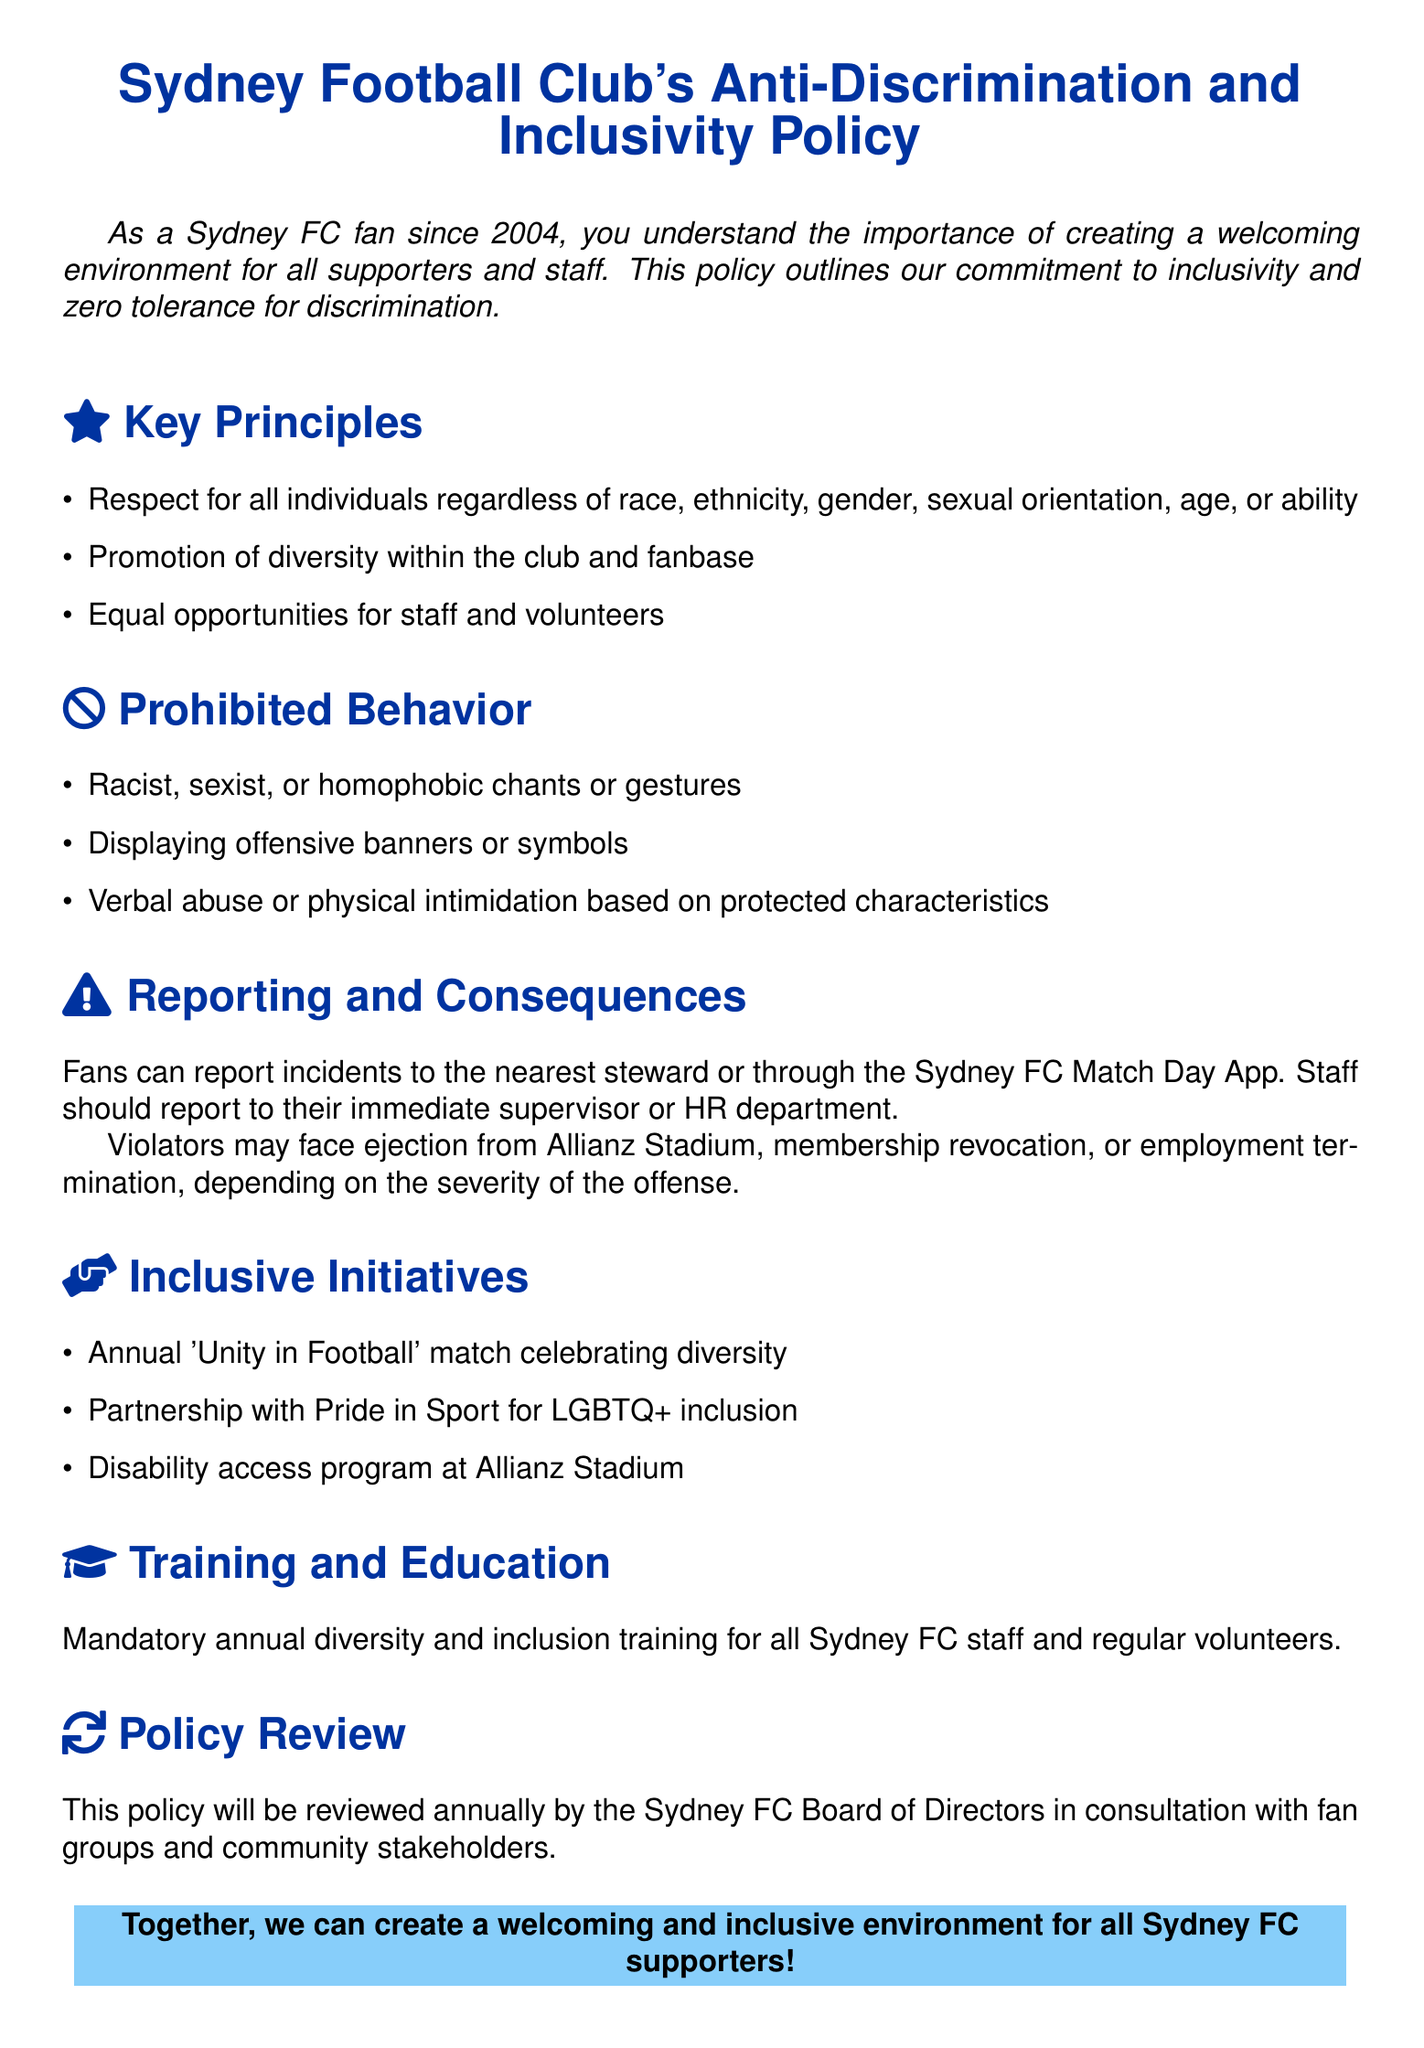What are the key principles of the policy? The key principles are outlined in the "Key Principles" section, which includes respect for all individuals, promotion of diversity, and equal opportunities.
Answer: Respect for all individuals, promotion of diversity, equal opportunities What actions are prohibited according to the policy? The prohibited behaviors are mentioned in the "Prohibited Behavior" section, which lists specific actions that violate the policy.
Answer: Racist, sexist, or homophobic chants or gestures, displaying offensive banners or symbols, verbal abuse or physical intimidation How can fans report incidents? The document states where incidents can be reported, specifically mentioning stewards and the match day app.
Answer: Nearest steward or through the Sydney FC Match Day App What are the potential consequences for violators? The document lists the possible consequences in the "Reporting and Consequences" section, detailing actions taken against offenders.
Answer: Ejection from Allianz Stadium, membership revocation, or employment termination What is the annual event celebrating diversity? The policy outlines an annual initiative aimed at celebrating diversity within the club and its fanbase.
Answer: 'Unity in Football' match What organization is partnered with Sydney FC for LGBTQ+ inclusion? The document mentions a specific organization involved in promoting LGBTQ+ inclusion among staff and fans.
Answer: Pride in Sport How often will the policy be reviewed? The review frequency of the policy is specified, indicating how often it will be assessed.
Answer: Annually What type of training is mandatory for staff? The policy states the type of training that all Sydney FC staff and volunteers are required to undertake.
Answer: Diversity and inclusion training 